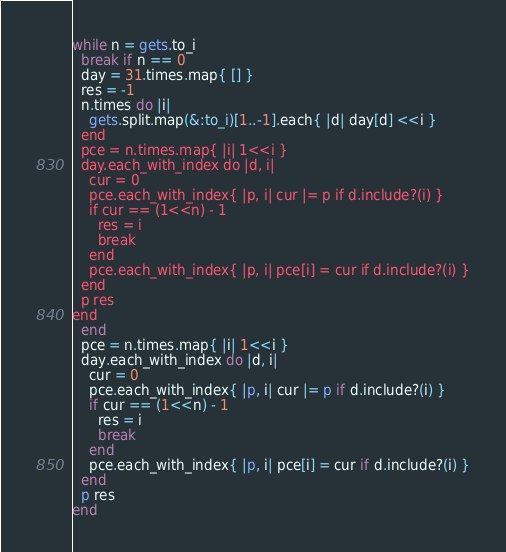<code> <loc_0><loc_0><loc_500><loc_500><_Ruby_>while n = gets.to_i
  break if n == 0
  day = 31.times.map{ [] }
  res = -1
  n.times do |i|
    gets.split.map(&:to_i)[1..-1].each{ |d| day[d] <<i }
  end
  pce = n.times.map{ |i| 1<<i }
  day.each_with_index do |d, i|
    cur = 0
    pce.each_with_index{ |p, i| cur |= p if d.include?(i) }
    if cur == (1<<n) - 1
      res = i
      break
    end
    pce.each_with_index{ |p, i| pce[i] = cur if d.include?(i) }
  end
  p res
end</code> 